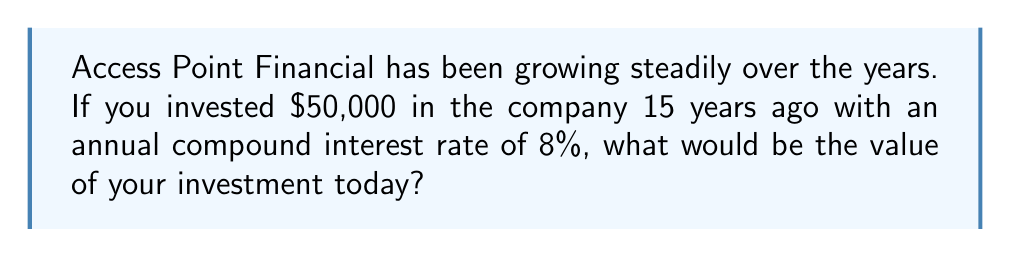Solve this math problem. To calculate the value of an investment with compound interest, we use the formula:

$$A = P(1 + r)^n$$

Where:
$A$ = Final amount
$P$ = Principal (initial investment)
$r$ = Annual interest rate (in decimal form)
$n$ = Number of years

Given:
$P = \$50,000$
$r = 8\% = 0.08$
$n = 15$ years

Let's substitute these values into the formula:

$$A = 50,000(1 + 0.08)^{15}$$

Now, let's calculate step by step:

1) First, calculate $(1 + 0.08)^{15}$:
   $$(1.08)^{15} \approx 3.1722$$

2) Multiply this by the principal:
   $$50,000 \times 3.1722 = 158,610$$

Therefore, after 15 years, the investment would grow to approximately $158,610.
Answer: $158,610 